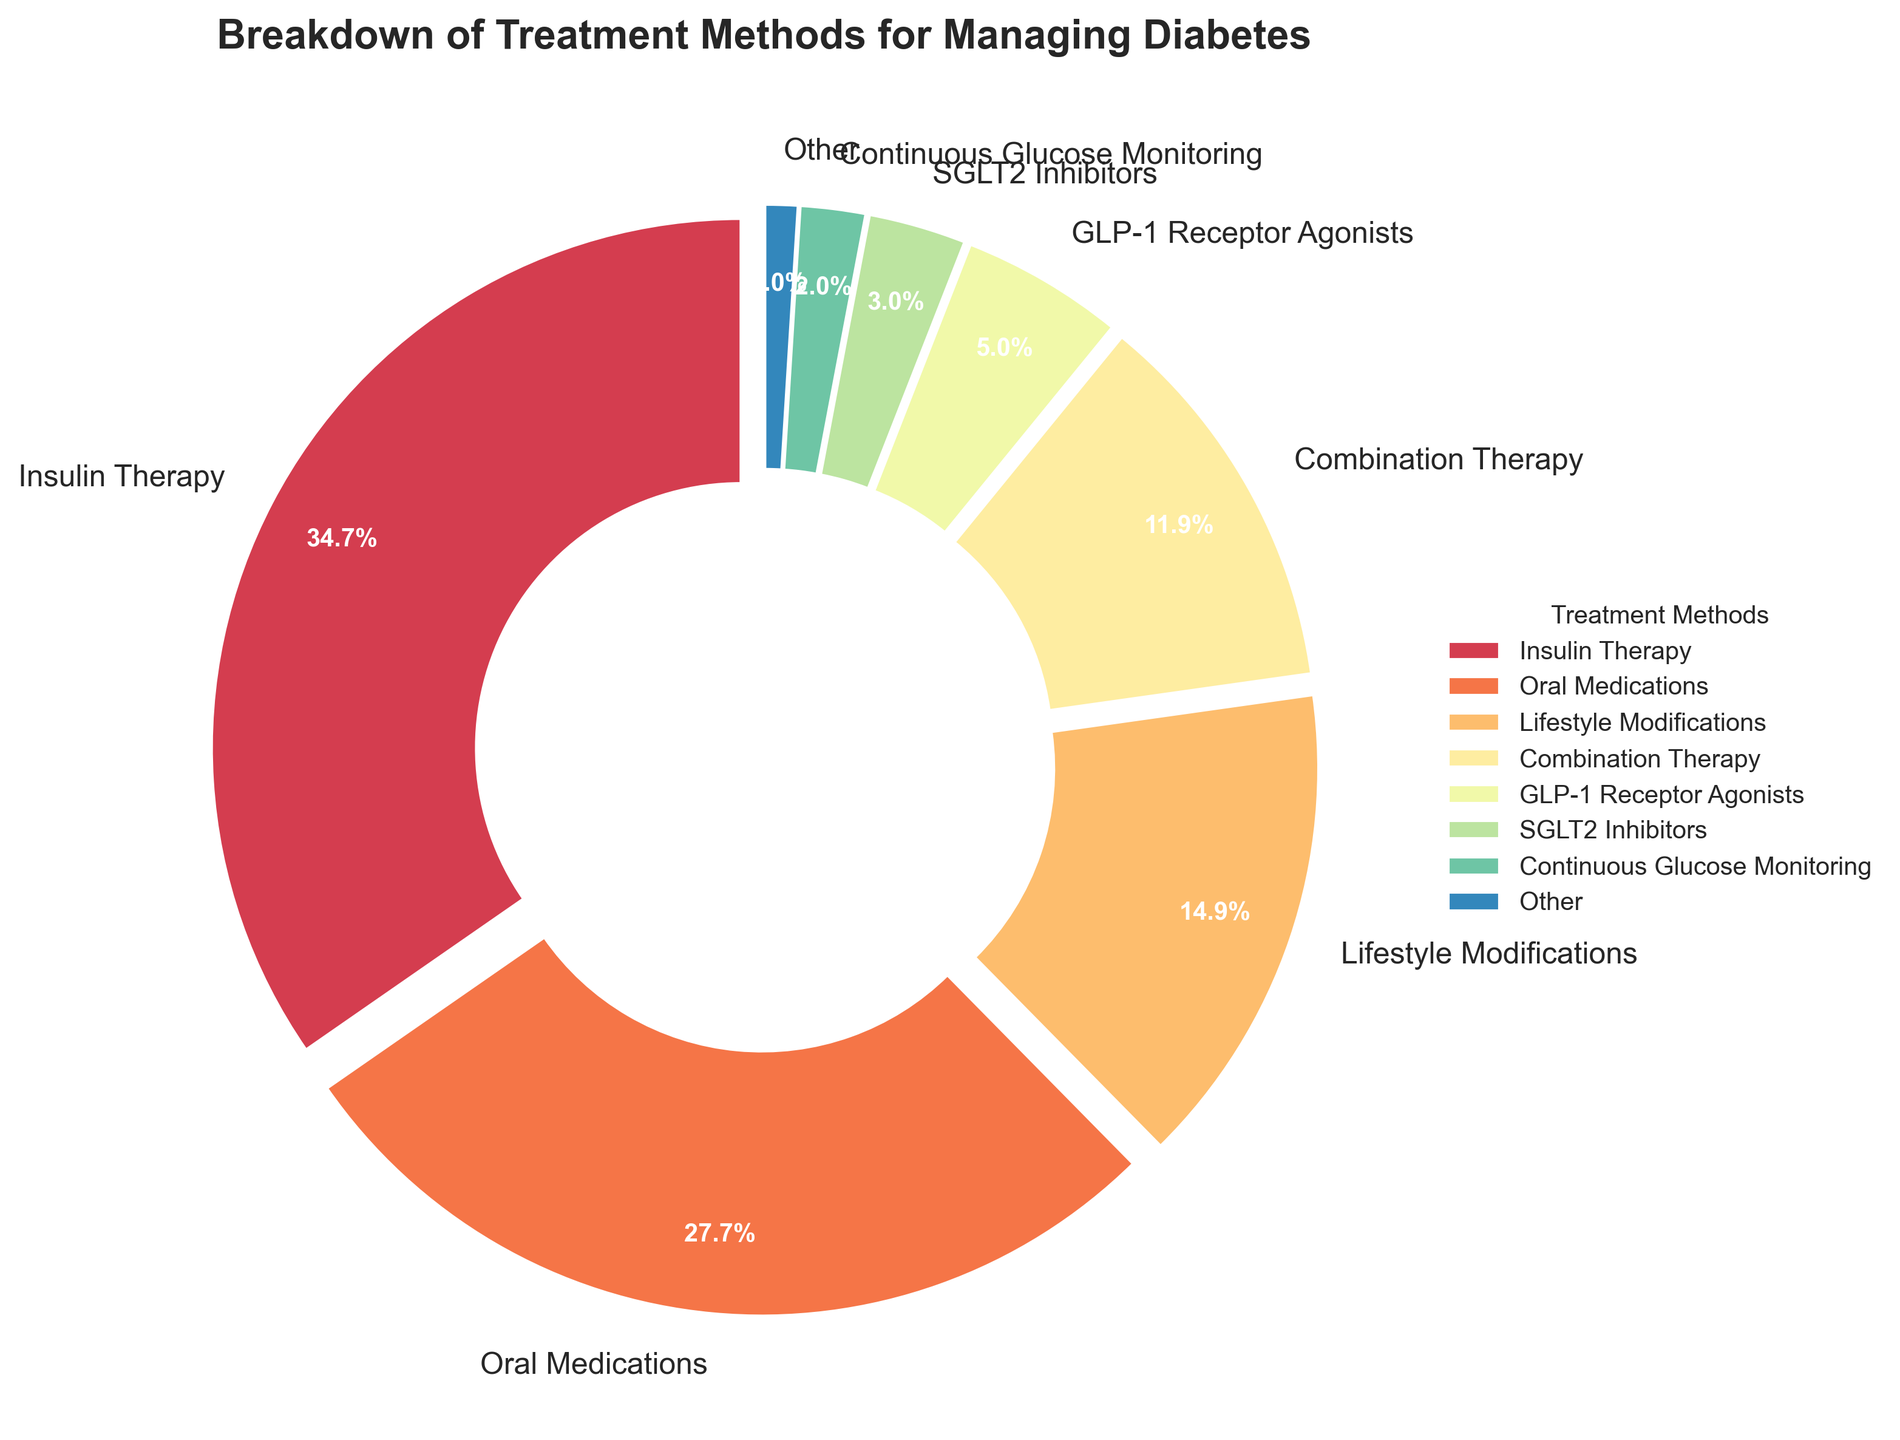Which treatment method is used most frequently? The largest section of the pie chart represents Insulin Therapy with a percentage of 35%.
Answer: Insulin Therapy What is the total percentage of treatments that include insulin (Insulin Therapy and Combination Therapy)? Combine the percentages of Insulin Therapy (35%) and Combination Therapy (12%), which equals 35 + 12 = 47%.
Answer: 47% How does the percentage of Lifestyle Modifications compare to Oral Medications? By observing the pie chart, Lifestyle Modifications is represented by 15% and Oral Medications by 28%. Thus, the difference is 28 - 15 = 13%.
Answer: 13% Which treatment methods are categorized under "Other"? SGLT2 Inhibitors (3%), Continuous Glucose Monitoring (2%), Pancreas Transplantation (0.5%), Islet Cell Transplantation (0.3%), and Artificial Pancreas Systems (0.2%) add up to be grouped into "Other".
Answer: SGLT2 Inhibitors, Continuous Glucose Monitoring, Pancreas Transplantation, Islet Cell Transplantation, Artificial Pancreas Systems What is the combined percentage of GLP-1 Receptor Agonists and SGLT2 Inhibitors? GLP-1 Receptor Agonists constitute 5% and SGLT2 Inhibitors possess 3%, adding these we get 5 + 3 = 8%.
Answer: 8% How does the representation of Combination Therapy visually compare to Insulin Therapy? In the pie chart, Combination Therapy has a visibly smaller section (12%) compared to the larger section of Insulin Therapy (35%).
Answer: Smaller Is Lifestyle Modifications a larger, smaller, or equal segment compared to the "Other" category? By the pie chart, Lifestyle Modifications represents 15%, whereas "Other" includes a combined segment of smaller segments and totals 6%. Hence, Lifestyle Modifications is larger.
Answer: Larger Which treatment method has the smallest representation? The smallest wedge in the pie chart corresponds to Artificial Pancreas Systems at 0.2%.
Answer: Artificial Pancreas Systems What is the sum percentage of treatments grouped under "Other"? Summing up the individual percentages of the treatments under "Other" yields: 3 + 2 + 0.5 + 0.3 + 0.2 = 6%.
Answer: 6% What percentage of the pie chart consists of non-drug-based treatments (Lifestyle Modifications, Continuous Glucose Monitoring, Pancreas Transplantation, Islet Cell Transplantation, Artificial Pancreas Systems)? Adding the non-drug-based treatments: 15% (Lifestyle Modifications) + 2% (Continuous Glucose Monitoring) + 0.5% (Pancreas Transplantation) + 0.3% (Islet Cell Transplantation) + 0.2% (Artificial Pancreas Systems) equals 15 + 2 + 0.5 + 0.3 + 0.2 = 18%.
Answer: 18% 